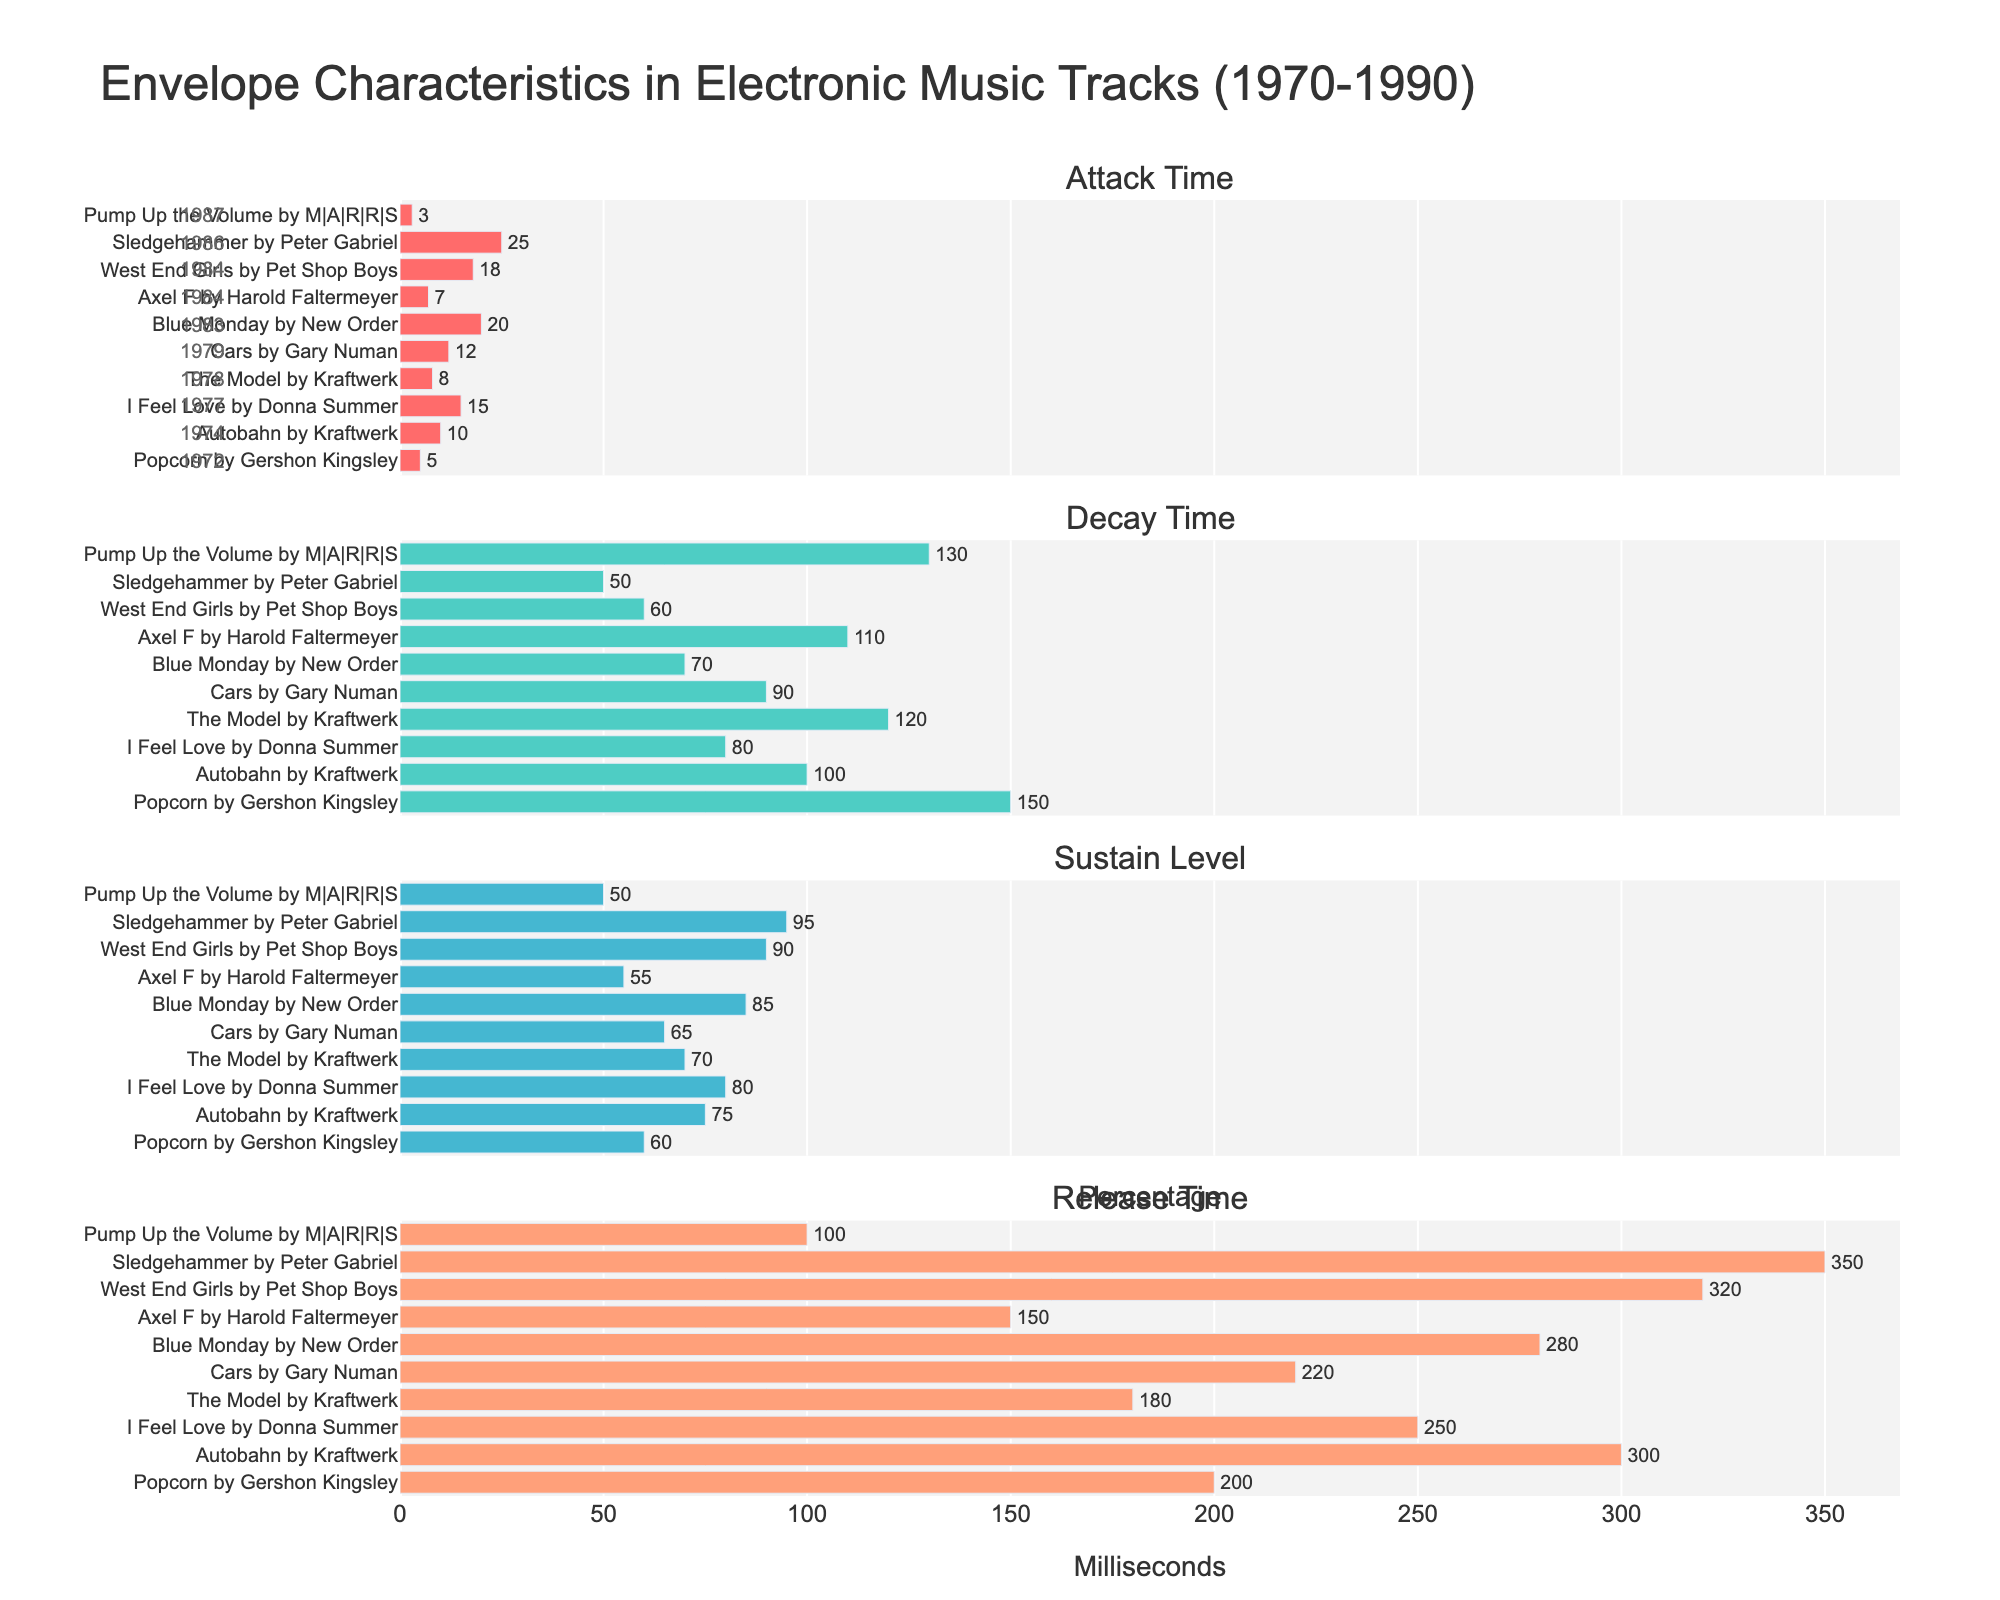Which track has the longest attack time? Look at the "Attack Time" subplot, find the longest bar and refer to its label
Answer: "Sledgehammer" by Peter Gabriel How many tracks have a sustain level of 80% or higher? From the "Sustain Level" subplot, count the bars with values of 80% or more
Answer: 5 Compare the decay times of the tracks "Popcorn" and "West End Girls". Which one is shorter? Look at the "Decay Time" subplot, find the bars for "Popcorn" and "West End Girls", and compare their lengths
Answer: "West End Girls" What is the average release time across all tracks? Sum the release times from the "Release Time" subplot and divide by the number of tracks. (200 + 300 + 250 + 180 + 220 + 280 + 150 + 320 + 350 + 100) / 10 = 235
Answer: 235 ms How does "Autobahn" by Kraftwerk's sustain level compare to the track with the highest sustain level? Find the sustain level for "Autobahn" (75%) and compare it to the highest level (95%) in the "Sustain Level" subplot
Answer: Lower than the highest What is the trend of attack times from 1972 to 1987? Observing the "Attack Time" subplot from top (1972) to bottom (1987), identify if times generally increase or decrease
Answer: General increase Find the difference in attack time between the tracks "I Feel Love" and "Axel F". From the "Attack Time" subplot, subtract the shorter bar's value (Axel F: 7 ms) from the larger bar's value (I Feel Love: 15 ms). 15 - 7 = 8
Answer: 8 ms Among the tracks listed, which has the highest decay time and what year was it released? Look at the "Decay Time" subplot, find the longest bar and refer to its year
Answer: "Popcorn" by Gershon Kingsley, 1972 